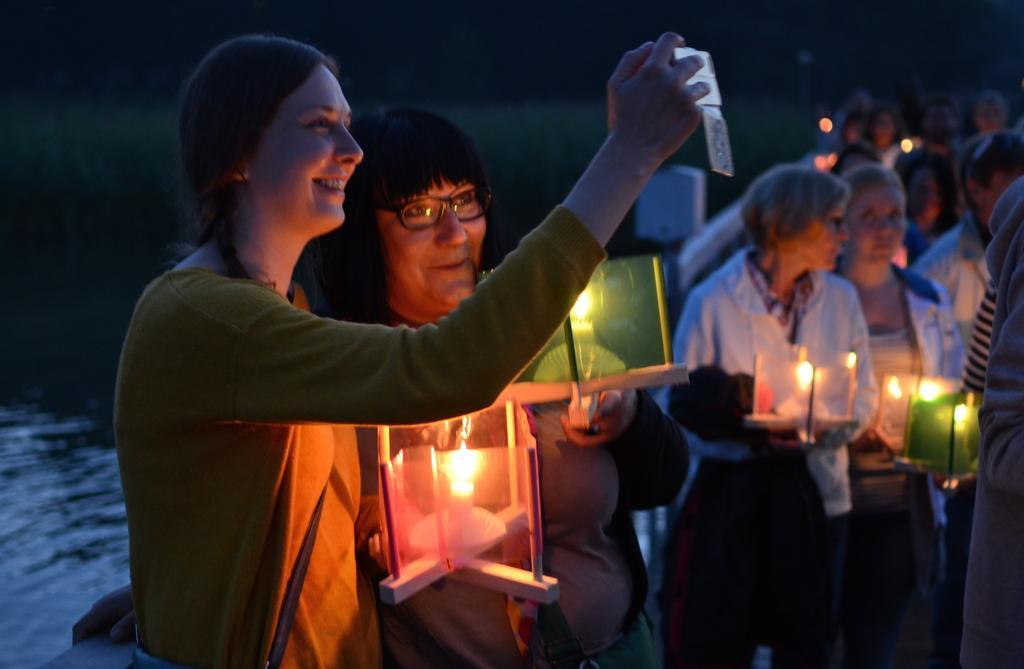In one or two sentences, can you explain what this image depicts? There are many people. Some are holding candle on a stand. Lady on the left side is wearing a bag and holding a mobile. Near to her another lady is wearing a specs. In the back there is water. And it is dark in the background. 